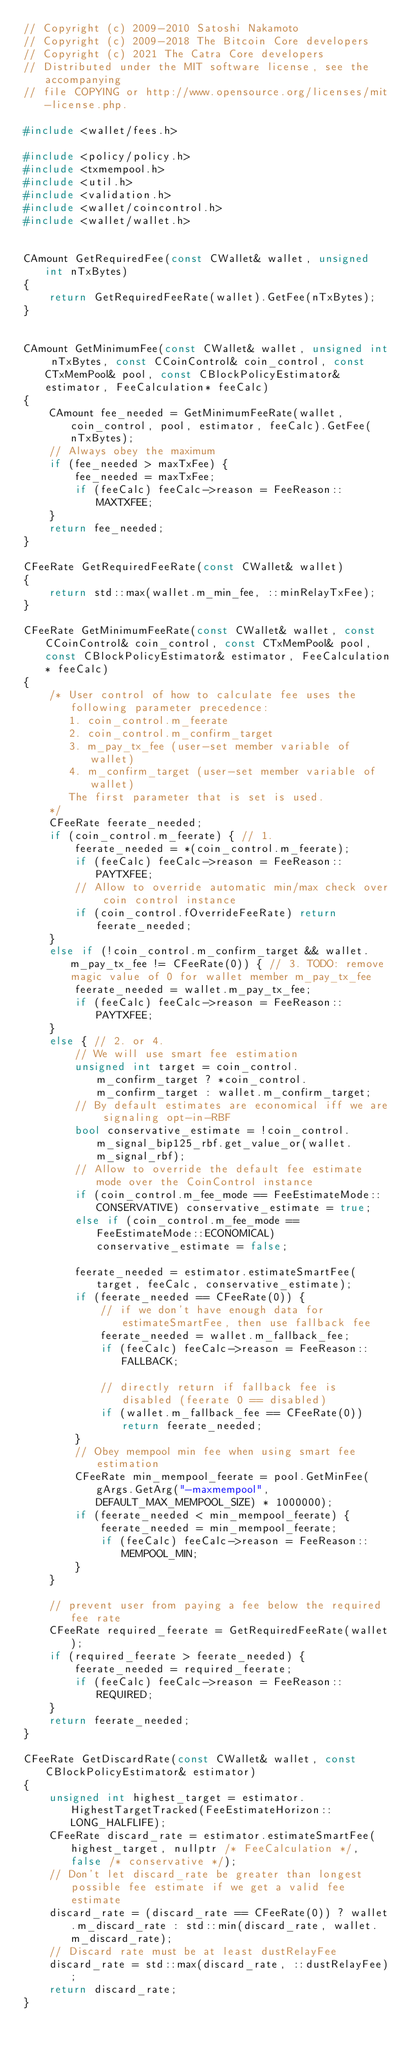Convert code to text. <code><loc_0><loc_0><loc_500><loc_500><_C++_>// Copyright (c) 2009-2010 Satoshi Nakamoto
// Copyright (c) 2009-2018 The Bitcoin Core developers
// Copyright (c) 2021 The Catra Core developers
// Distributed under the MIT software license, see the accompanying
// file COPYING or http://www.opensource.org/licenses/mit-license.php.

#include <wallet/fees.h>

#include <policy/policy.h>
#include <txmempool.h>
#include <util.h>
#include <validation.h>
#include <wallet/coincontrol.h>
#include <wallet/wallet.h>


CAmount GetRequiredFee(const CWallet& wallet, unsigned int nTxBytes)
{
    return GetRequiredFeeRate(wallet).GetFee(nTxBytes);
}


CAmount GetMinimumFee(const CWallet& wallet, unsigned int nTxBytes, const CCoinControl& coin_control, const CTxMemPool& pool, const CBlockPolicyEstimator& estimator, FeeCalculation* feeCalc)
{
    CAmount fee_needed = GetMinimumFeeRate(wallet, coin_control, pool, estimator, feeCalc).GetFee(nTxBytes);
    // Always obey the maximum
    if (fee_needed > maxTxFee) {
        fee_needed = maxTxFee;
        if (feeCalc) feeCalc->reason = FeeReason::MAXTXFEE;
    }
    return fee_needed;
}

CFeeRate GetRequiredFeeRate(const CWallet& wallet)
{
    return std::max(wallet.m_min_fee, ::minRelayTxFee);
}

CFeeRate GetMinimumFeeRate(const CWallet& wallet, const CCoinControl& coin_control, const CTxMemPool& pool, const CBlockPolicyEstimator& estimator, FeeCalculation* feeCalc)
{
    /* User control of how to calculate fee uses the following parameter precedence:
       1. coin_control.m_feerate
       2. coin_control.m_confirm_target
       3. m_pay_tx_fee (user-set member variable of wallet)
       4. m_confirm_target (user-set member variable of wallet)
       The first parameter that is set is used.
    */
    CFeeRate feerate_needed;
    if (coin_control.m_feerate) { // 1.
        feerate_needed = *(coin_control.m_feerate);
        if (feeCalc) feeCalc->reason = FeeReason::PAYTXFEE;
        // Allow to override automatic min/max check over coin control instance
        if (coin_control.fOverrideFeeRate) return feerate_needed;
    }
    else if (!coin_control.m_confirm_target && wallet.m_pay_tx_fee != CFeeRate(0)) { // 3. TODO: remove magic value of 0 for wallet member m_pay_tx_fee
        feerate_needed = wallet.m_pay_tx_fee;
        if (feeCalc) feeCalc->reason = FeeReason::PAYTXFEE;
    }
    else { // 2. or 4.
        // We will use smart fee estimation
        unsigned int target = coin_control.m_confirm_target ? *coin_control.m_confirm_target : wallet.m_confirm_target;
        // By default estimates are economical iff we are signaling opt-in-RBF
        bool conservative_estimate = !coin_control.m_signal_bip125_rbf.get_value_or(wallet.m_signal_rbf);
        // Allow to override the default fee estimate mode over the CoinControl instance
        if (coin_control.m_fee_mode == FeeEstimateMode::CONSERVATIVE) conservative_estimate = true;
        else if (coin_control.m_fee_mode == FeeEstimateMode::ECONOMICAL) conservative_estimate = false;

        feerate_needed = estimator.estimateSmartFee(target, feeCalc, conservative_estimate);
        if (feerate_needed == CFeeRate(0)) {
            // if we don't have enough data for estimateSmartFee, then use fallback fee
            feerate_needed = wallet.m_fallback_fee;
            if (feeCalc) feeCalc->reason = FeeReason::FALLBACK;

            // directly return if fallback fee is disabled (feerate 0 == disabled)
            if (wallet.m_fallback_fee == CFeeRate(0)) return feerate_needed;
        }
        // Obey mempool min fee when using smart fee estimation
        CFeeRate min_mempool_feerate = pool.GetMinFee(gArgs.GetArg("-maxmempool", DEFAULT_MAX_MEMPOOL_SIZE) * 1000000);
        if (feerate_needed < min_mempool_feerate) {
            feerate_needed = min_mempool_feerate;
            if (feeCalc) feeCalc->reason = FeeReason::MEMPOOL_MIN;
        }
    }

    // prevent user from paying a fee below the required fee rate
    CFeeRate required_feerate = GetRequiredFeeRate(wallet);
    if (required_feerate > feerate_needed) {
        feerate_needed = required_feerate;
        if (feeCalc) feeCalc->reason = FeeReason::REQUIRED;
    }
    return feerate_needed;
}

CFeeRate GetDiscardRate(const CWallet& wallet, const CBlockPolicyEstimator& estimator)
{
    unsigned int highest_target = estimator.HighestTargetTracked(FeeEstimateHorizon::LONG_HALFLIFE);
    CFeeRate discard_rate = estimator.estimateSmartFee(highest_target, nullptr /* FeeCalculation */, false /* conservative */);
    // Don't let discard_rate be greater than longest possible fee estimate if we get a valid fee estimate
    discard_rate = (discard_rate == CFeeRate(0)) ? wallet.m_discard_rate : std::min(discard_rate, wallet.m_discard_rate);
    // Discard rate must be at least dustRelayFee
    discard_rate = std::max(discard_rate, ::dustRelayFee);
    return discard_rate;
}
</code> 